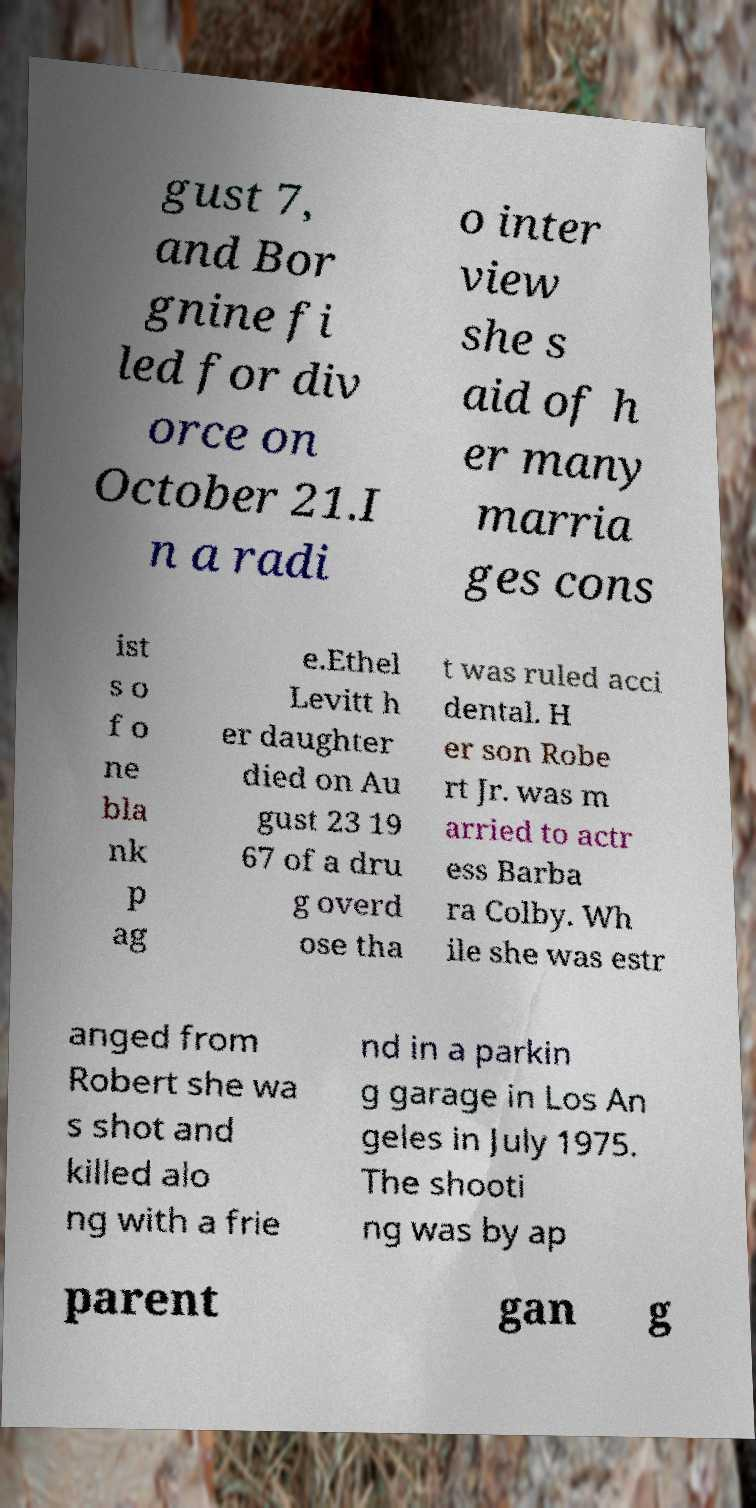Can you accurately transcribe the text from the provided image for me? gust 7, and Bor gnine fi led for div orce on October 21.I n a radi o inter view she s aid of h er many marria ges cons ist s o f o ne bla nk p ag e.Ethel Levitt h er daughter died on Au gust 23 19 67 of a dru g overd ose tha t was ruled acci dental. H er son Robe rt Jr. was m arried to actr ess Barba ra Colby. Wh ile she was estr anged from Robert she wa s shot and killed alo ng with a frie nd in a parkin g garage in Los An geles in July 1975. The shooti ng was by ap parent gan g 